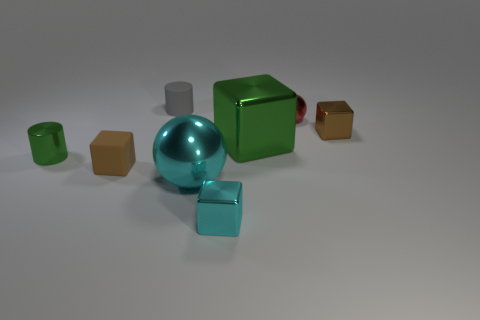Subtract all large green metallic blocks. How many blocks are left? 3 Subtract all cyan cubes. How many cubes are left? 3 Subtract all yellow blocks. Subtract all green cylinders. How many blocks are left? 4 Add 1 cyan metallic spheres. How many objects exist? 9 Subtract all cylinders. How many objects are left? 6 Subtract 0 blue blocks. How many objects are left? 8 Subtract all small blue cylinders. Subtract all cubes. How many objects are left? 4 Add 6 small matte cylinders. How many small matte cylinders are left? 7 Add 3 big green metallic cubes. How many big green metallic cubes exist? 4 